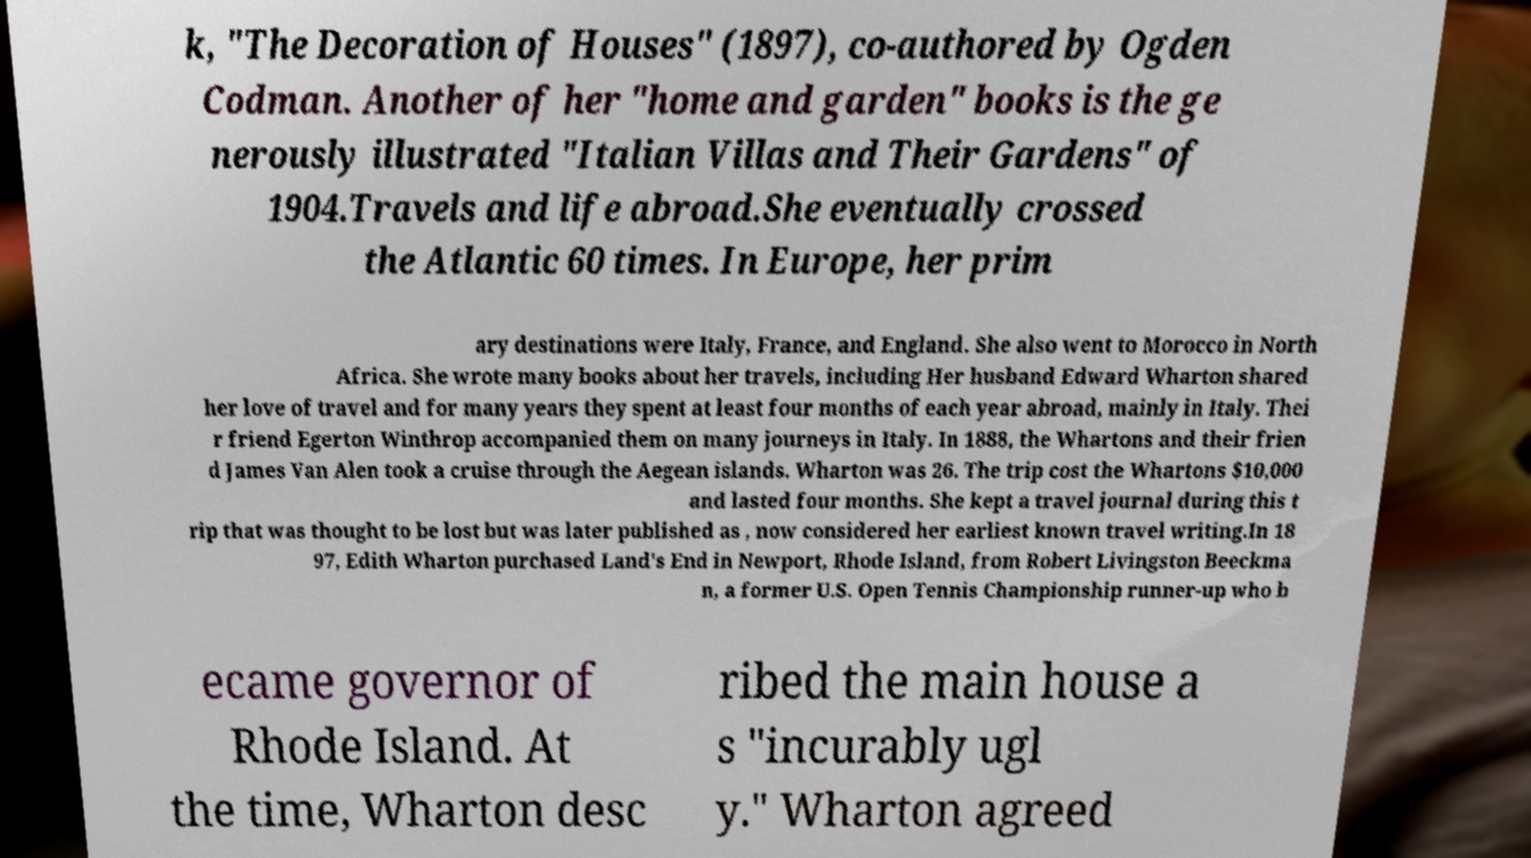Please identify and transcribe the text found in this image. k, "The Decoration of Houses" (1897), co-authored by Ogden Codman. Another of her "home and garden" books is the ge nerously illustrated "Italian Villas and Their Gardens" of 1904.Travels and life abroad.She eventually crossed the Atlantic 60 times. In Europe, her prim ary destinations were Italy, France, and England. She also went to Morocco in North Africa. She wrote many books about her travels, including Her husband Edward Wharton shared her love of travel and for many years they spent at least four months of each year abroad, mainly in Italy. Thei r friend Egerton Winthrop accompanied them on many journeys in Italy. In 1888, the Whartons and their frien d James Van Alen took a cruise through the Aegean islands. Wharton was 26. The trip cost the Whartons $10,000 and lasted four months. She kept a travel journal during this t rip that was thought to be lost but was later published as , now considered her earliest known travel writing.In 18 97, Edith Wharton purchased Land's End in Newport, Rhode Island, from Robert Livingston Beeckma n, a former U.S. Open Tennis Championship runner-up who b ecame governor of Rhode Island. At the time, Wharton desc ribed the main house a s "incurably ugl y." Wharton agreed 